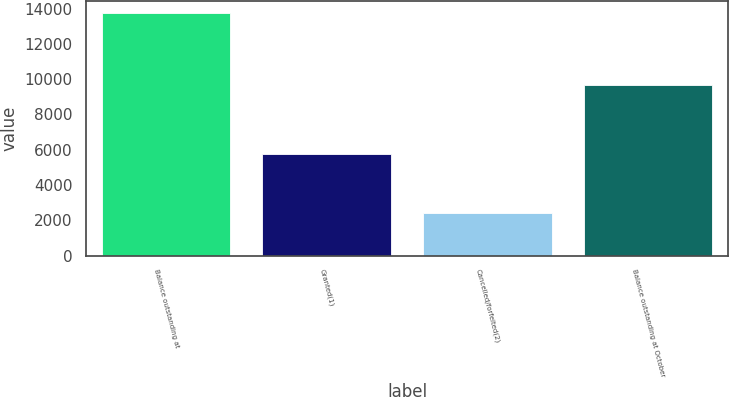Convert chart. <chart><loc_0><loc_0><loc_500><loc_500><bar_chart><fcel>Balance outstanding at<fcel>Granted(1)<fcel>Cancelled/forfeited(2)<fcel>Balance outstanding at October<nl><fcel>13754<fcel>5770<fcel>2386<fcel>9679.5<nl></chart> 